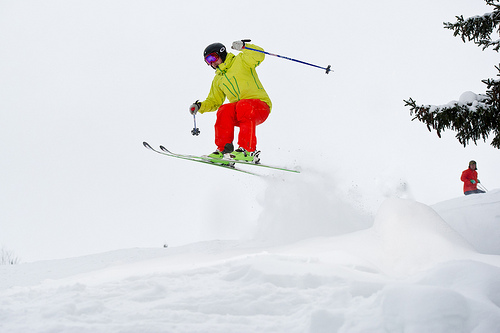Please provide a short description for this region: [0.88, 0.47, 0.99, 0.59]. A distant skier can be seen in the background, identifiable by their red-colored jacket and black hat against the white snow. 